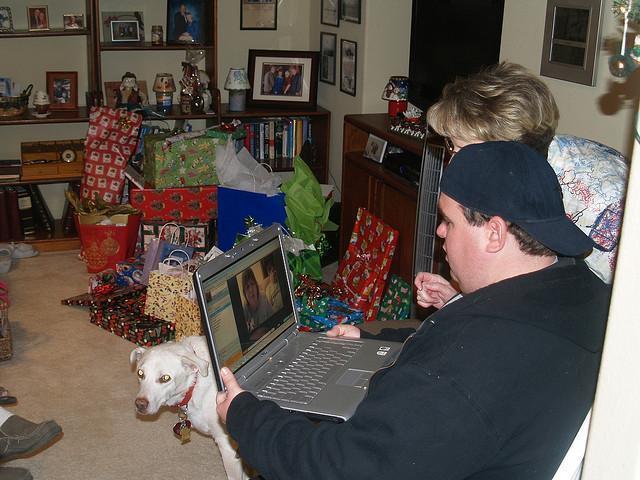What came in all those colored boxes?
From the following four choices, select the correct answer to address the question.
Options: Blankets, carpet, food, presents. Presents. 